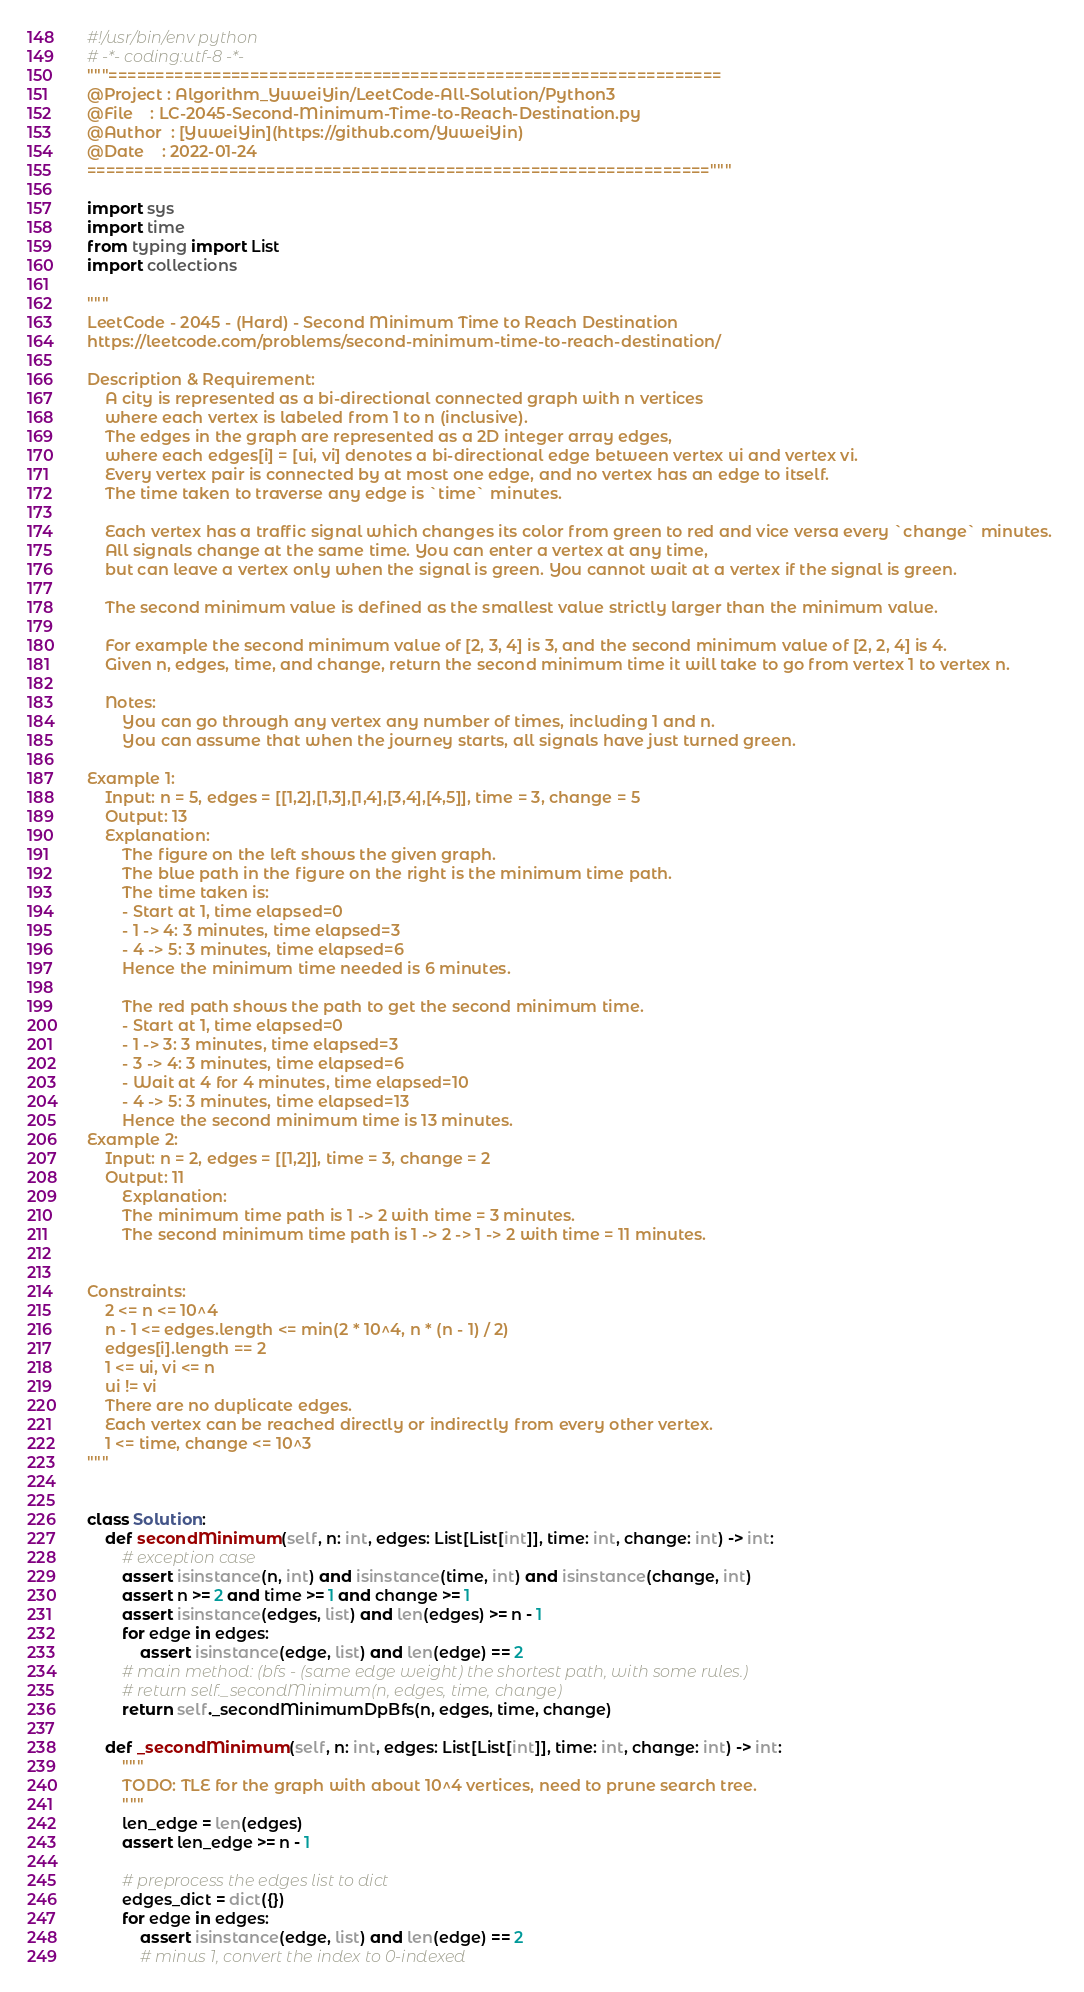<code> <loc_0><loc_0><loc_500><loc_500><_Python_>#!/usr/bin/env python
# -*- coding:utf-8 -*-
"""=================================================================
@Project : Algorithm_YuweiYin/LeetCode-All-Solution/Python3
@File    : LC-2045-Second-Minimum-Time-to-Reach-Destination.py
@Author  : [YuweiYin](https://github.com/YuweiYin)
@Date    : 2022-01-24
=================================================================="""

import sys
import time
from typing import List
import collections

"""
LeetCode - 2045 - (Hard) - Second Minimum Time to Reach Destination
https://leetcode.com/problems/second-minimum-time-to-reach-destination/

Description & Requirement:
    A city is represented as a bi-directional connected graph with n vertices 
    where each vertex is labeled from 1 to n (inclusive). 
    The edges in the graph are represented as a 2D integer array edges, 
    where each edges[i] = [ui, vi] denotes a bi-directional edge between vertex ui and vertex vi. 
    Every vertex pair is connected by at most one edge, and no vertex has an edge to itself. 
    The time taken to traverse any edge is `time` minutes.

    Each vertex has a traffic signal which changes its color from green to red and vice versa every `change` minutes. 
    All signals change at the same time. You can enter a vertex at any time, 
    but can leave a vertex only when the signal is green. You cannot wait at a vertex if the signal is green.

    The second minimum value is defined as the smallest value strictly larger than the minimum value.

    For example the second minimum value of [2, 3, 4] is 3, and the second minimum value of [2, 2, 4] is 4.
    Given n, edges, time, and change, return the second minimum time it will take to go from vertex 1 to vertex n.

    Notes:
        You can go through any vertex any number of times, including 1 and n.
        You can assume that when the journey starts, all signals have just turned green.

Example 1:
    Input: n = 5, edges = [[1,2],[1,3],[1,4],[3,4],[4,5]], time = 3, change = 5
    Output: 13
    Explanation:
        The figure on the left shows the given graph.
        The blue path in the figure on the right is the minimum time path.
        The time taken is:
        - Start at 1, time elapsed=0
        - 1 -> 4: 3 minutes, time elapsed=3
        - 4 -> 5: 3 minutes, time elapsed=6
        Hence the minimum time needed is 6 minutes.
        
        The red path shows the path to get the second minimum time.
        - Start at 1, time elapsed=0
        - 1 -> 3: 3 minutes, time elapsed=3
        - 3 -> 4: 3 minutes, time elapsed=6
        - Wait at 4 for 4 minutes, time elapsed=10
        - 4 -> 5: 3 minutes, time elapsed=13
        Hence the second minimum time is 13 minutes.      
Example 2:
    Input: n = 2, edges = [[1,2]], time = 3, change = 2
    Output: 11
        Explanation:
        The minimum time path is 1 -> 2 with time = 3 minutes.
        The second minimum time path is 1 -> 2 -> 1 -> 2 with time = 11 minutes.
 

Constraints:
    2 <= n <= 10^4
    n - 1 <= edges.length <= min(2 * 10^4, n * (n - 1) / 2)
    edges[i].length == 2
    1 <= ui, vi <= n
    ui != vi
    There are no duplicate edges.
    Each vertex can be reached directly or indirectly from every other vertex.
    1 <= time, change <= 10^3
"""


class Solution:
    def secondMinimum(self, n: int, edges: List[List[int]], time: int, change: int) -> int:
        # exception case
        assert isinstance(n, int) and isinstance(time, int) and isinstance(change, int)
        assert n >= 2 and time >= 1 and change >= 1
        assert isinstance(edges, list) and len(edges) >= n - 1
        for edge in edges:
            assert isinstance(edge, list) and len(edge) == 2
        # main method: (bfs - (same edge weight) the shortest path, with some rules.)
        # return self._secondMinimum(n, edges, time, change)
        return self._secondMinimumDpBfs(n, edges, time, change)

    def _secondMinimum(self, n: int, edges: List[List[int]], time: int, change: int) -> int:
        """
        TODO: TLE for the graph with about 10^4 vertices, need to prune search tree.
        """
        len_edge = len(edges)
        assert len_edge >= n - 1

        # preprocess the edges list to dict
        edges_dict = dict({})
        for edge in edges:
            assert isinstance(edge, list) and len(edge) == 2
            # minus 1, convert the index to 0-indexed</code> 